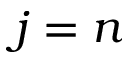Convert formula to latex. <formula><loc_0><loc_0><loc_500><loc_500>j = n</formula> 